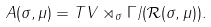Convert formula to latex. <formula><loc_0><loc_0><loc_500><loc_500>A ( \sigma , \mu ) = T V \rtimes _ { \sigma } \Gamma / ( \mathcal { R } ( \sigma , \mu ) ) .</formula> 